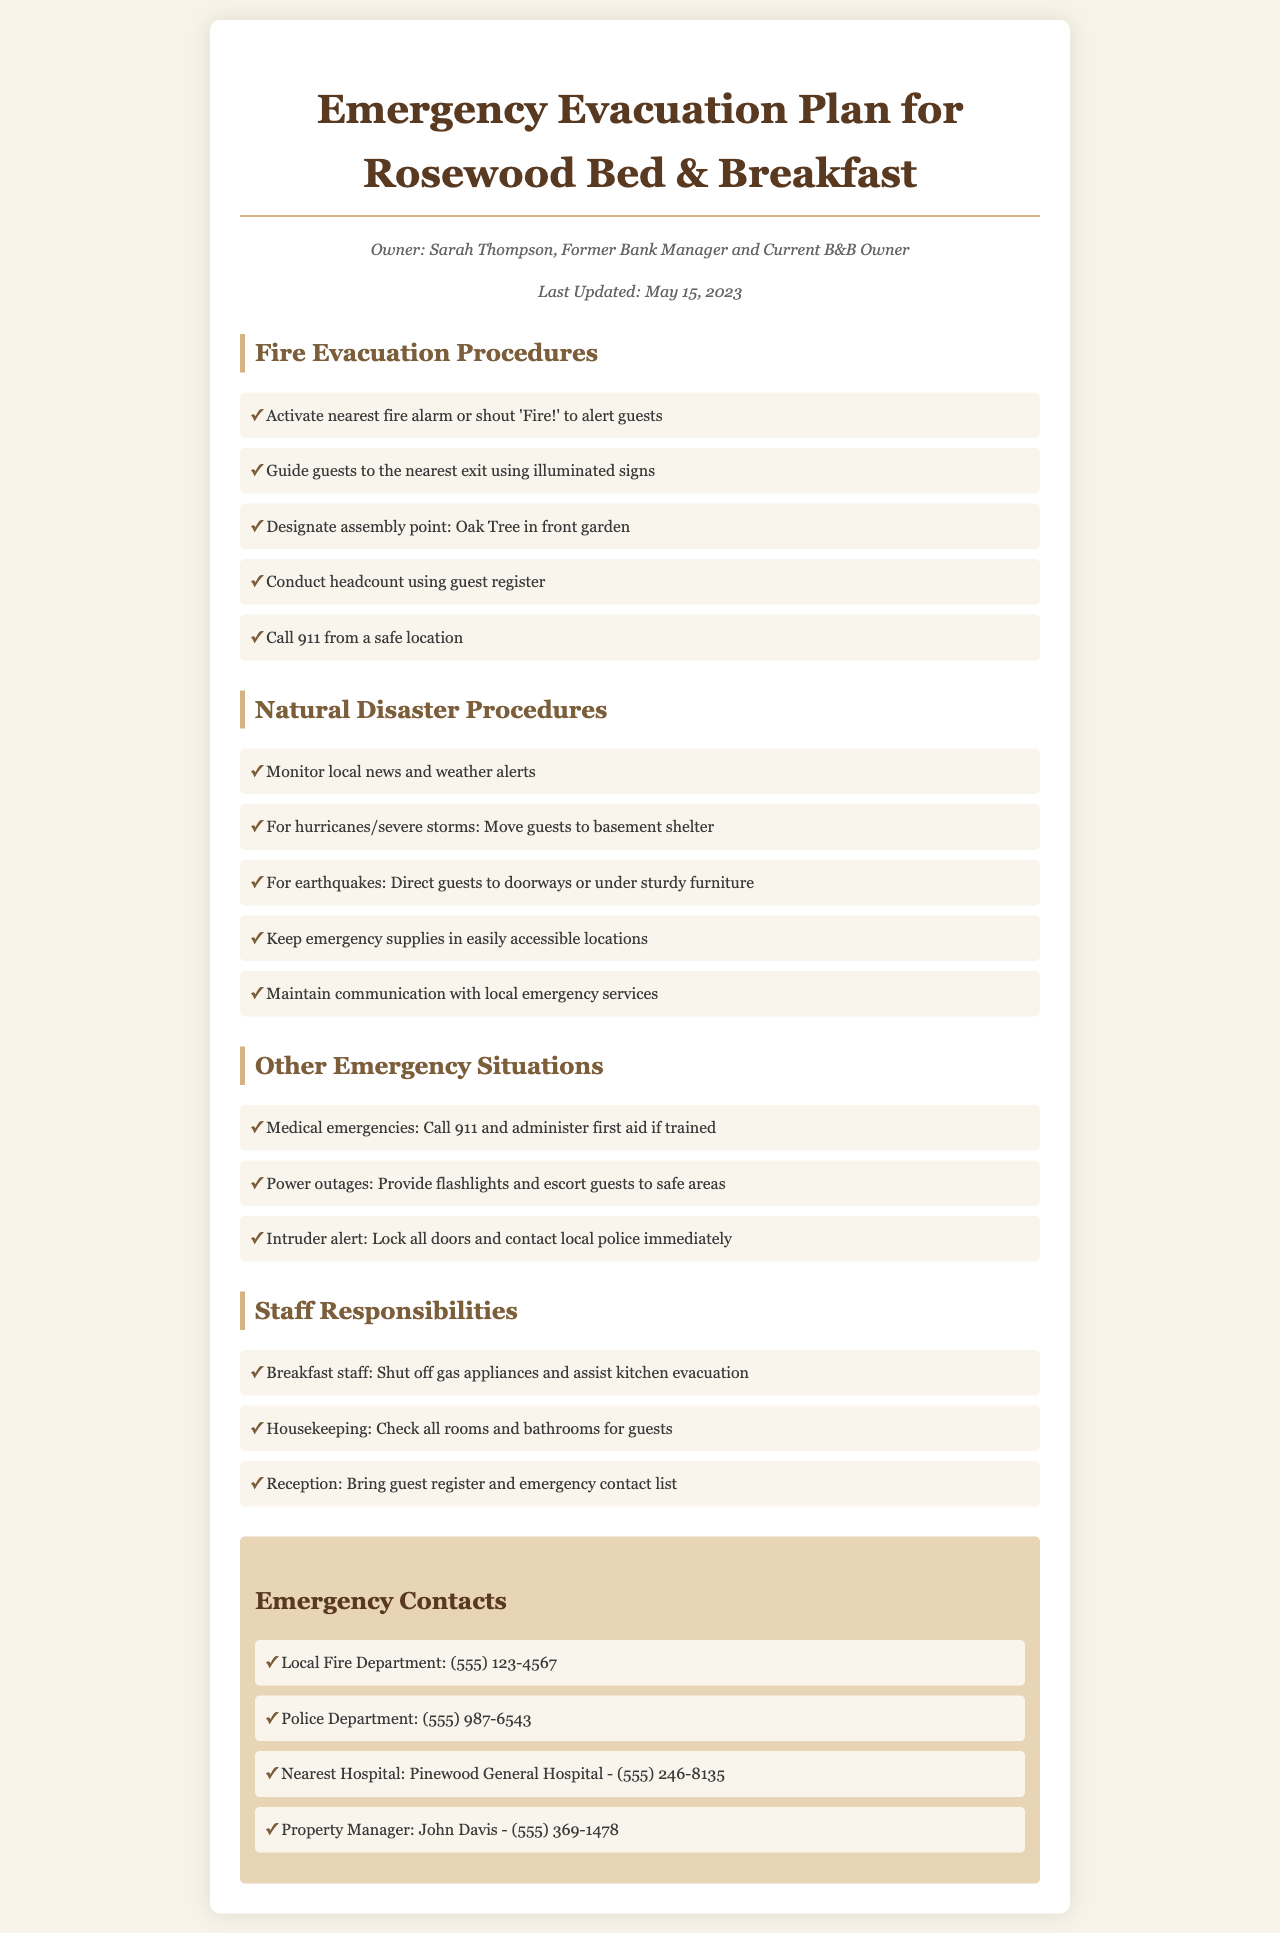what is the name of the owner? The document states the owner's name is Sarah Thompson.
Answer: Sarah Thompson when was the document last updated? The document specifies the last update date as May 15, 2023.
Answer: May 15, 2023 what is the emergency contact number for the local fire department? The document lists the local fire department's number as (555) 123-4567.
Answer: (555) 123-4567 where is the designated assembly point for fire evacuation? The document indicates the assembly point is the Oak Tree in the front garden.
Answer: Oak Tree in front garden what should guests do during a hurricane? The natural disaster procedures direct guests to move to the basement shelter.
Answer: Move to basement shelter who is responsible for checking all rooms and bathrooms during an emergency? The document states that housekeeping is responsible for this task.
Answer: Housekeeping how should guests alert others in case of a fire? Guests should activate the nearest fire alarm or shout 'Fire!' to alert others.
Answer: Activate nearest fire alarm or shout 'Fire!' what action should be taken during a medical emergency? The document suggests calling 911 and administering first aid if trained.
Answer: Call 911 and administer first aid what should the breakfast staff do during an evacuation? The breakfast staff should shut off gas appliances and assist kitchen evacuation.
Answer: Shut off gas appliances and assist kitchen evacuation 